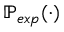Convert formula to latex. <formula><loc_0><loc_0><loc_500><loc_500>\mathbb { P } _ { e x p } ( \cdot )</formula> 